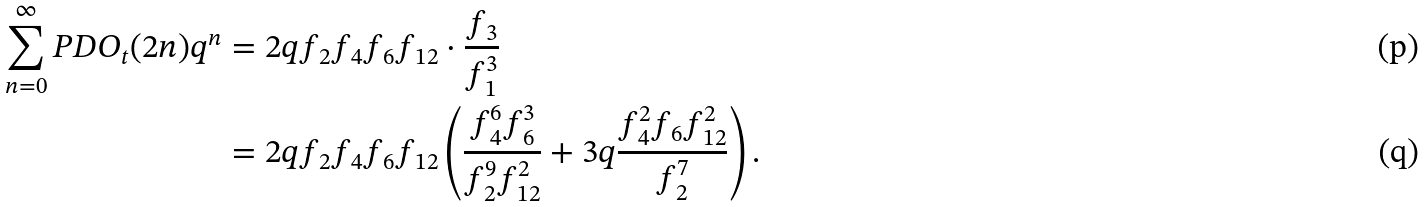<formula> <loc_0><loc_0><loc_500><loc_500>\sum _ { n = 0 } ^ { \infty } P D O _ { t } ( 2 n ) q ^ { n } & = 2 q { f _ { 2 } f _ { 4 } f _ { 6 } f _ { 1 2 } } \cdot \frac { f _ { 3 } } { f _ { 1 } ^ { 3 } } \\ & = 2 q { f _ { 2 } f _ { 4 } f _ { 6 } f _ { 1 2 } } \left ( \frac { f _ { 4 } ^ { 6 } f _ { 6 } ^ { 3 } } { f _ { 2 } ^ { 9 } f _ { 1 2 } ^ { 2 } } + 3 q \frac { f _ { 4 } ^ { 2 } f _ { 6 } f _ { 1 2 } ^ { 2 } } { f _ { 2 } ^ { 7 } } \right ) .</formula> 